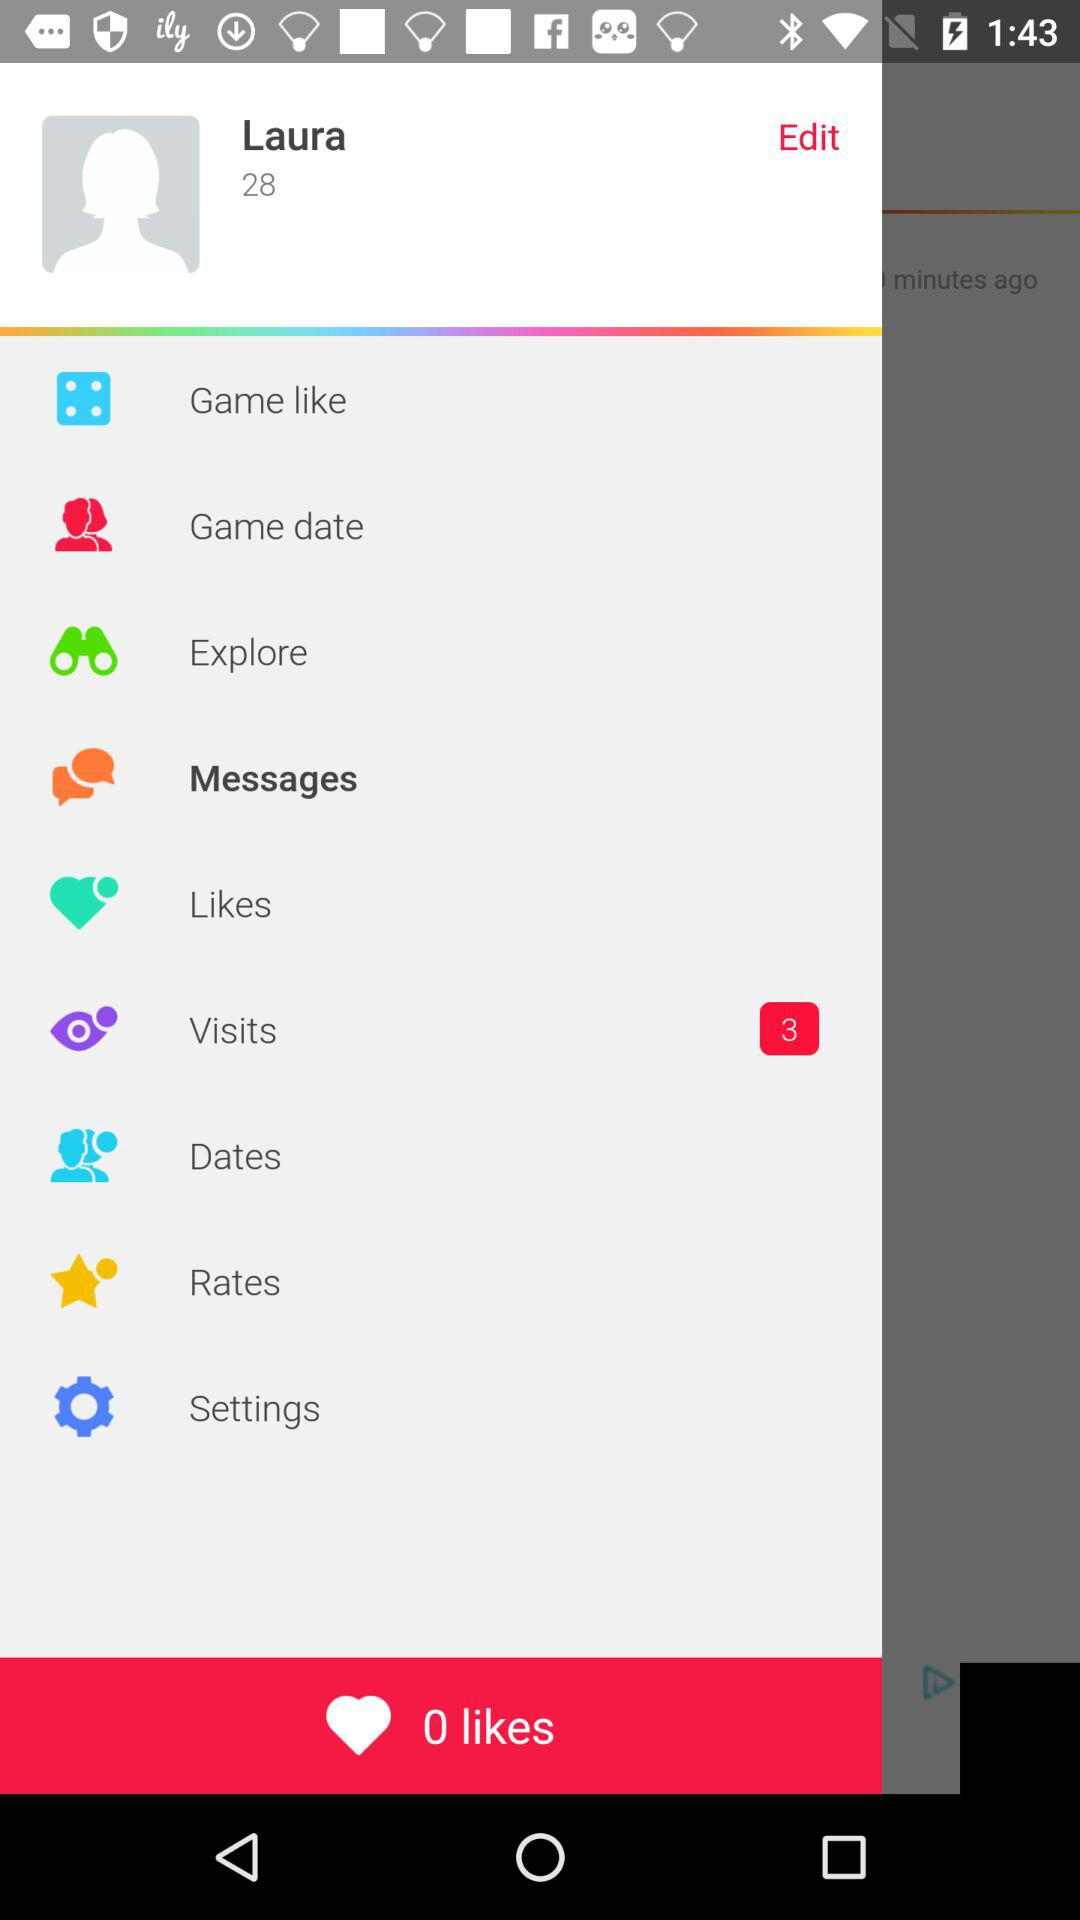How many visits did the profile have? The profile had 3 visits. 